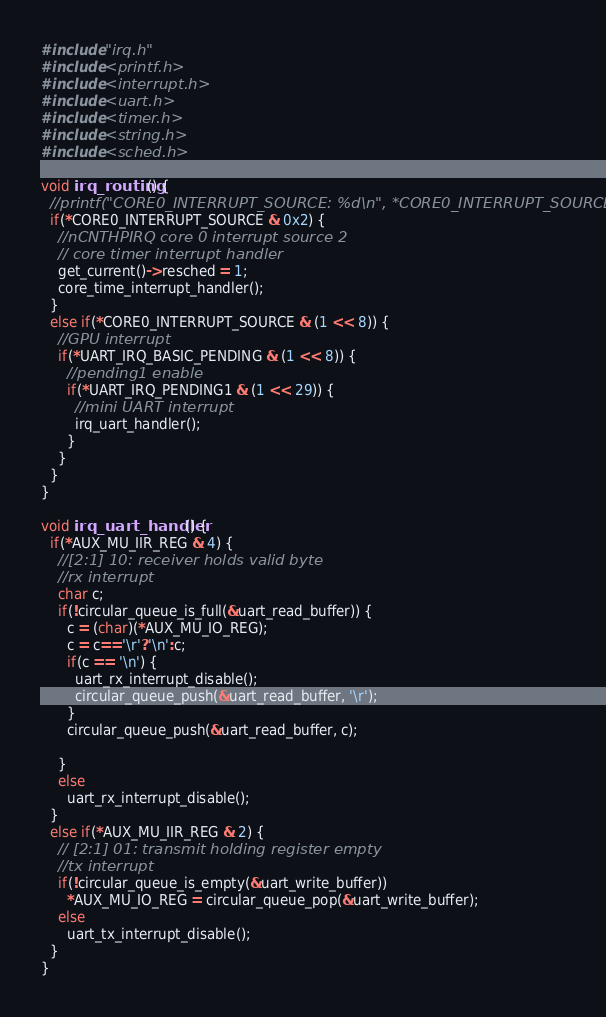<code> <loc_0><loc_0><loc_500><loc_500><_C_>#include "irq.h"
#include <printf.h>
#include <interrupt.h>
#include <uart.h>
#include <timer.h>
#include <string.h>
#include <sched.h>

void irq_routing() {
  //printf("CORE0_INTERRUPT_SOURCE: %d\n", *CORE0_INTERRUPT_SOURCE);
  if(*CORE0_INTERRUPT_SOURCE & 0x2) {
    //nCNTHPIRQ core 0 interrupt source 2
    // core timer interrupt handler
    get_current()->resched = 1;
    core_time_interrupt_handler();
  }
  else if(*CORE0_INTERRUPT_SOURCE & (1 << 8)) {
    //GPU interrupt
    if(*UART_IRQ_BASIC_PENDING & (1 << 8)) {
      //pending1 enable
      if(*UART_IRQ_PENDING1 & (1 << 29)) {
        //mini UART interrupt
        irq_uart_handler();
      }
    }
  }
}

void irq_uart_handler() {
  if(*AUX_MU_IIR_REG & 4) {
    //[2:1] 10: receiver holds valid byte
    //rx interrupt
    char c; 
    if(!circular_queue_is_full(&uart_read_buffer)) {
      c = (char)(*AUX_MU_IO_REG);
      c = c=='\r'?'\n':c;
      if(c == '\n') {
        uart_rx_interrupt_disable();
        circular_queue_push(&uart_read_buffer, '\r'); 
      }
      circular_queue_push(&uart_read_buffer, c); 
      
    }
    else
      uart_rx_interrupt_disable();
  }
  else if(*AUX_MU_IIR_REG & 2) {
    // [2:1] 01: transmit holding register empty
    //tx interrupt
    if(!circular_queue_is_empty(&uart_write_buffer))
      *AUX_MU_IO_REG = circular_queue_pop(&uart_write_buffer);
    else 
      uart_tx_interrupt_disable();
  }
}</code> 